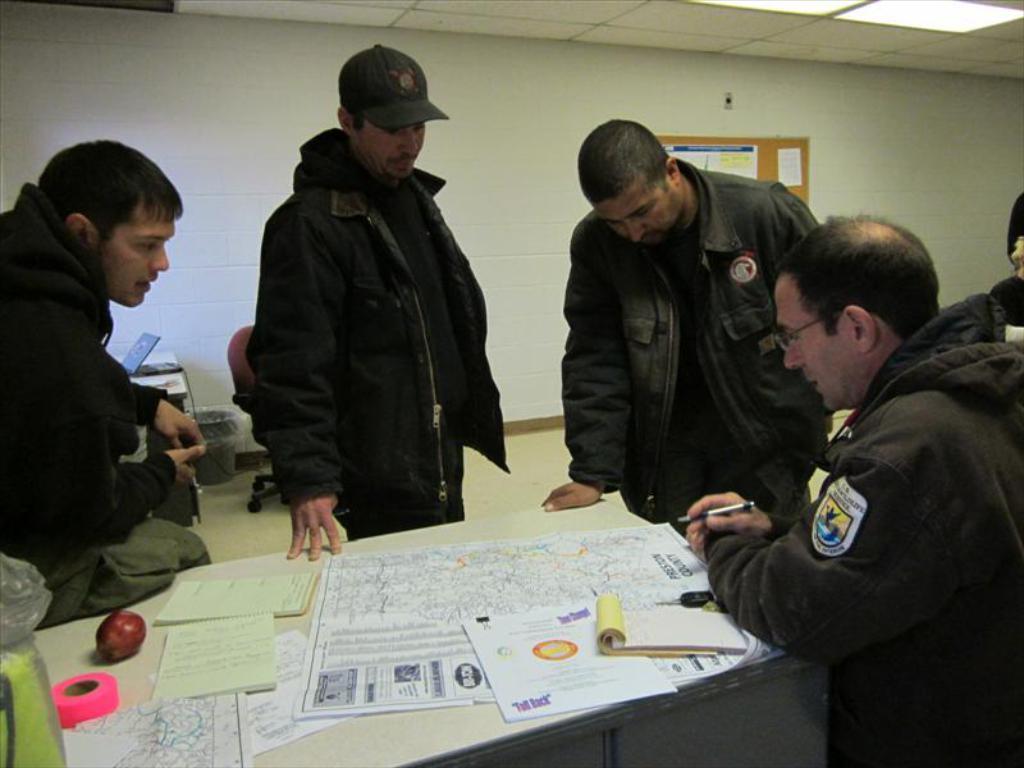How would you summarize this image in a sentence or two? In this image there are some people some of them are standing, and some of them are sitting and they are talking something. And at the bottom there is a table, on the table there are some papers, books, apple, tape and some object. And in the background there is wall, on the wall there are some posters and on the left side there is a table. On the table there is a laptop beside the table there is a dustbin, and one chair. At the top there is ceiling and lights. 